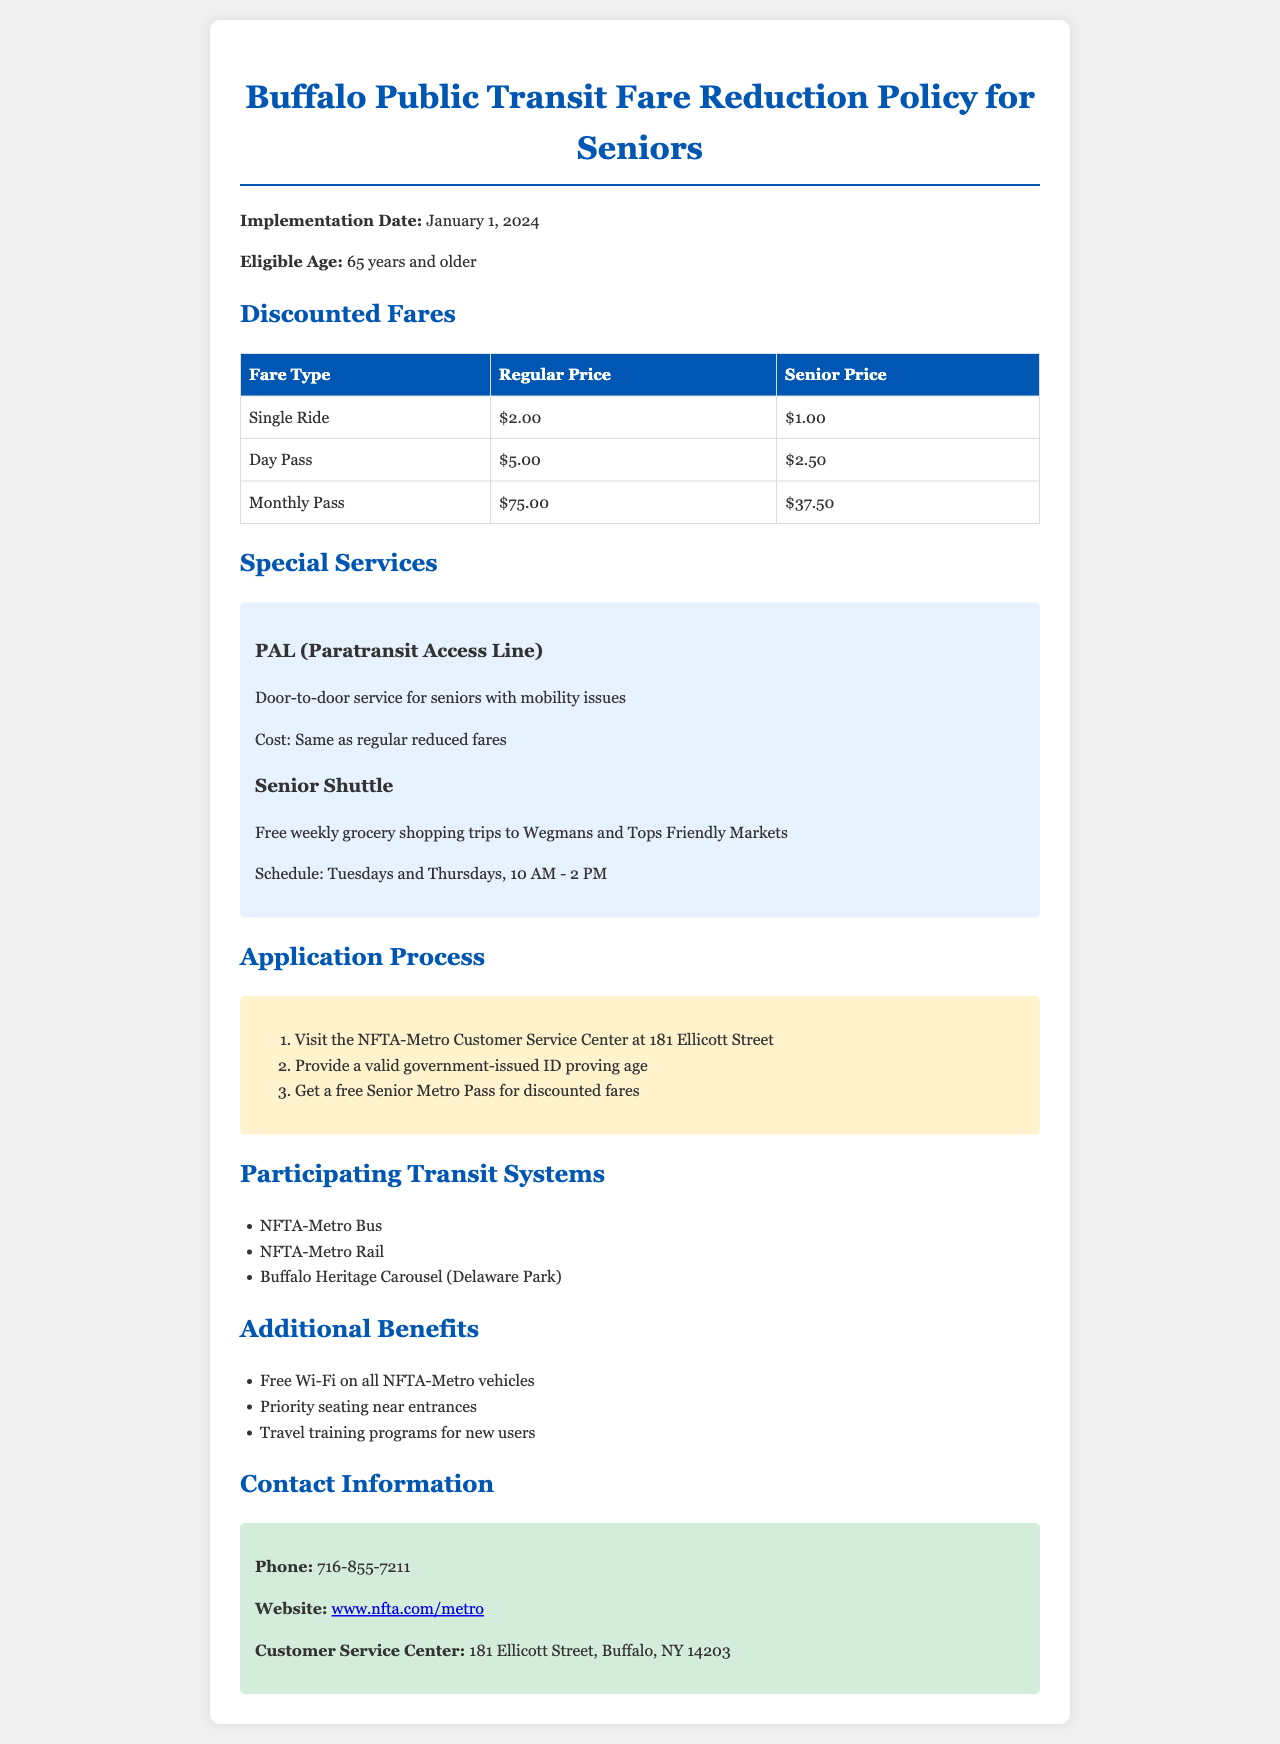What is the implementation date of the policy? The implementation date is stated in the document as January 1, 2024.
Answer: January 1, 2024 What is the age eligibility for discounted fares? The document specifies that individuals aged 65 years and older are eligible.
Answer: 65 years and older What is the senior fare for a single ride? The single ride fare for seniors in the document is provided as $1.00.
Answer: $1.00 What are the days and times for the Senior Shuttle service? The Senior Shuttle is scheduled for Tuesdays and Thursdays from 10 AM to 2 PM as mentioned in the document.
Answer: Tuesdays and Thursdays, 10 AM - 2 PM What identification is required to apply for the Senior Metro Pass? The document states a valid government-issued ID proving age must be provided.
Answer: Valid government-issued ID How many transit systems participate in this fare reduction policy? The document lists three participating transit systems.
Answer: Three What is the cost of the PAL service for seniors? According to the document, the cost for the PAL service is the same as regular reduced fares.
Answer: Same as regular reduced fares Is there free Wi-Fi available on the transit vehicles? The document mentions that free Wi-Fi is available on all NFTA-Metro vehicles.
Answer: Yes What is the contact phone number for inquiries? The document provides the contact phone number as 716-855-7211.
Answer: 716-855-7211 